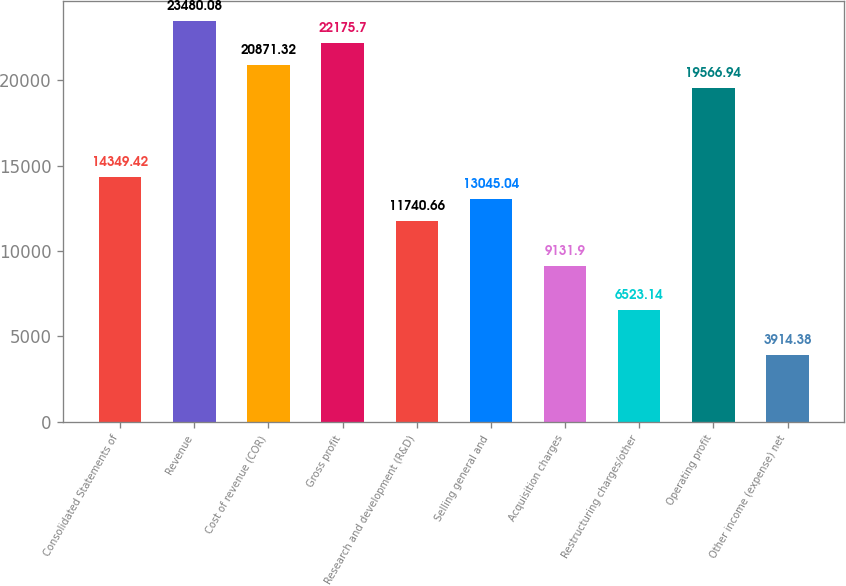Convert chart to OTSL. <chart><loc_0><loc_0><loc_500><loc_500><bar_chart><fcel>Consolidated Statements of<fcel>Revenue<fcel>Cost of revenue (COR)<fcel>Gross profit<fcel>Research and development (R&D)<fcel>Selling general and<fcel>Acquisition charges<fcel>Restructuring charges/other<fcel>Operating profit<fcel>Other income (expense) net<nl><fcel>14349.4<fcel>23480.1<fcel>20871.3<fcel>22175.7<fcel>11740.7<fcel>13045<fcel>9131.9<fcel>6523.14<fcel>19566.9<fcel>3914.38<nl></chart> 